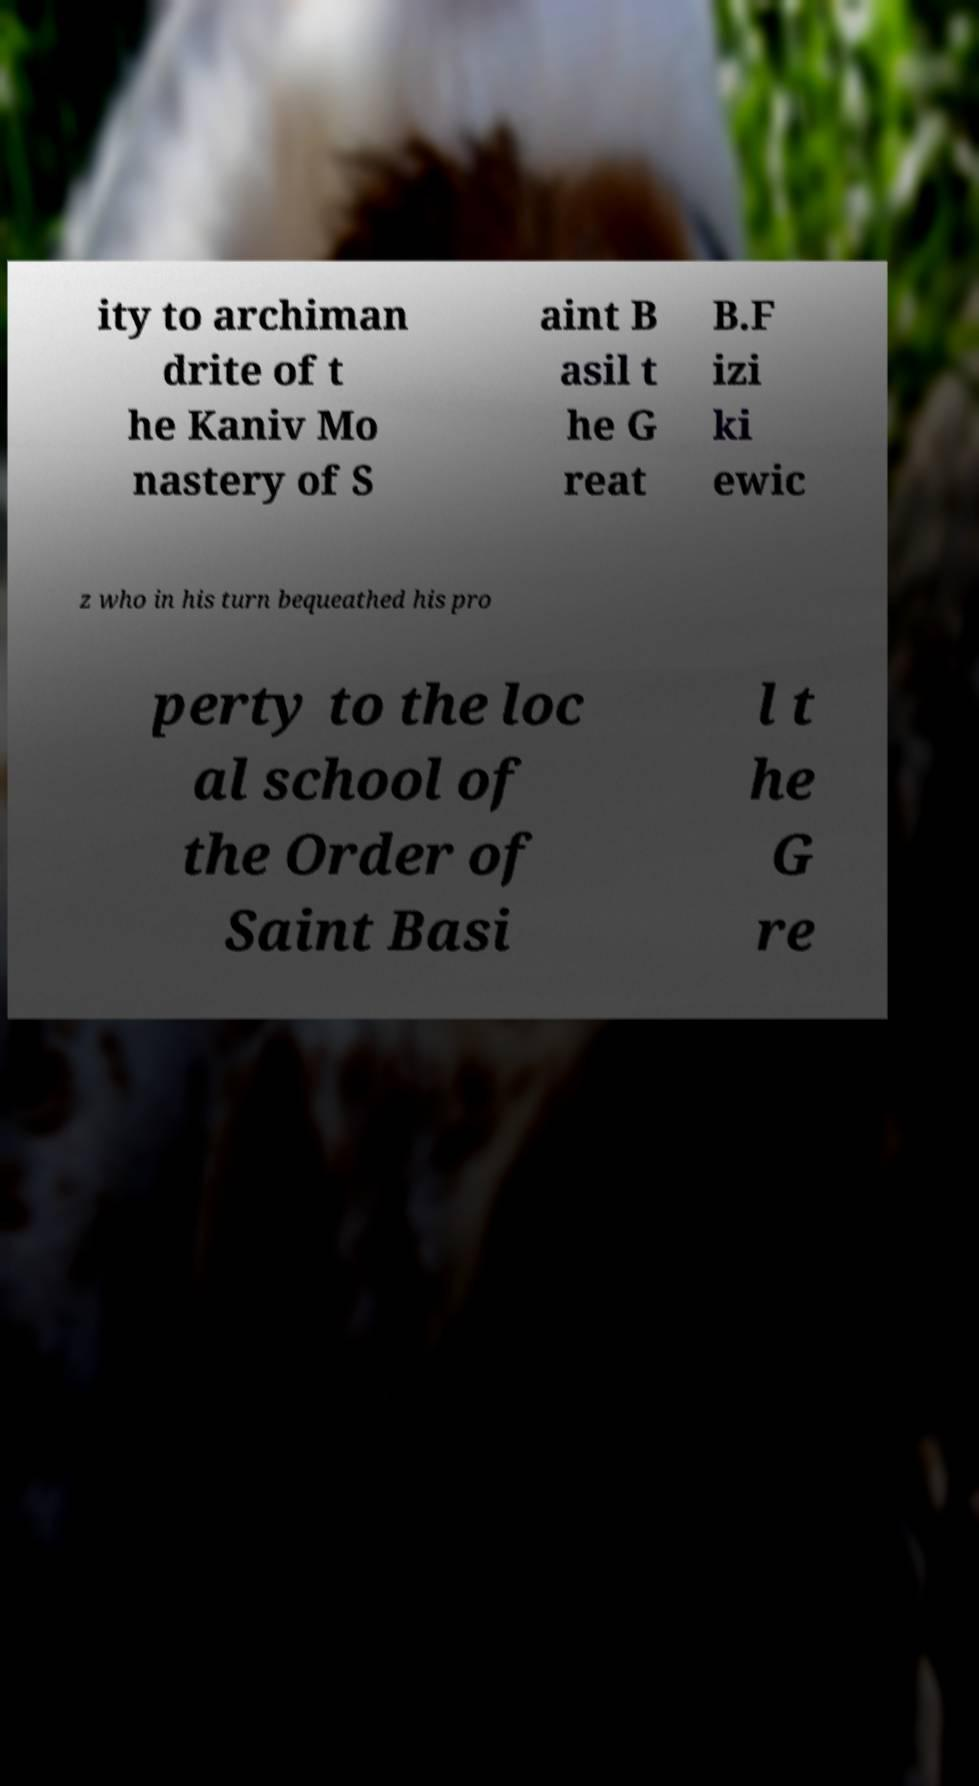For documentation purposes, I need the text within this image transcribed. Could you provide that? ity to archiman drite of t he Kaniv Mo nastery of S aint B asil t he G reat B.F izi ki ewic z who in his turn bequeathed his pro perty to the loc al school of the Order of Saint Basi l t he G re 